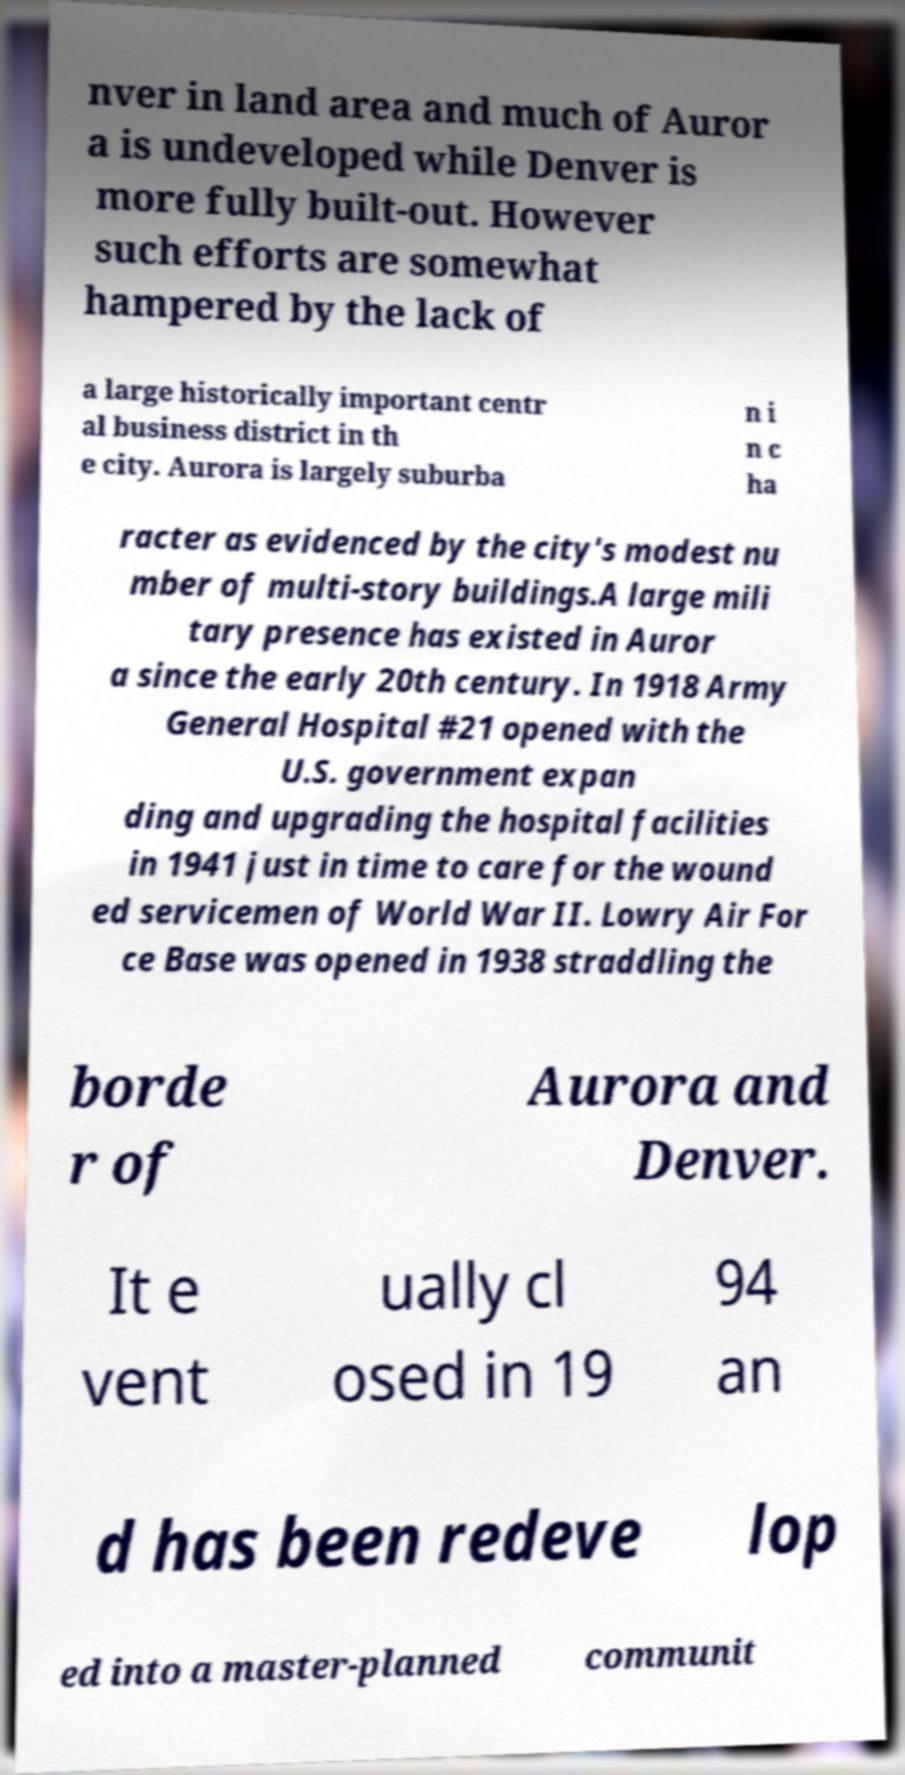Can you accurately transcribe the text from the provided image for me? nver in land area and much of Auror a is undeveloped while Denver is more fully built-out. However such efforts are somewhat hampered by the lack of a large historically important centr al business district in th e city. Aurora is largely suburba n i n c ha racter as evidenced by the city's modest nu mber of multi-story buildings.A large mili tary presence has existed in Auror a since the early 20th century. In 1918 Army General Hospital #21 opened with the U.S. government expan ding and upgrading the hospital facilities in 1941 just in time to care for the wound ed servicemen of World War II. Lowry Air For ce Base was opened in 1938 straddling the borde r of Aurora and Denver. It e vent ually cl osed in 19 94 an d has been redeve lop ed into a master-planned communit 